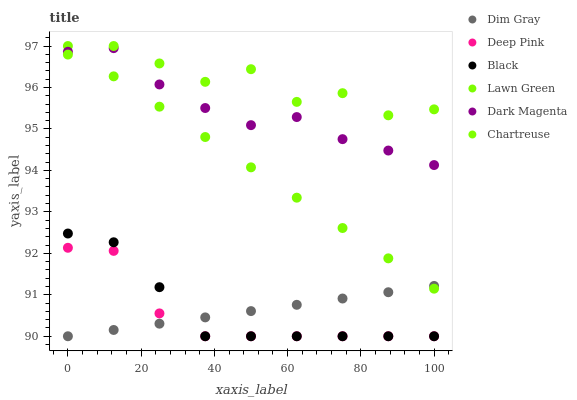Does Deep Pink have the minimum area under the curve?
Answer yes or no. Yes. Does Chartreuse have the maximum area under the curve?
Answer yes or no. Yes. Does Dim Gray have the minimum area under the curve?
Answer yes or no. No. Does Dim Gray have the maximum area under the curve?
Answer yes or no. No. Is Lawn Green the smoothest?
Answer yes or no. Yes. Is Chartreuse the roughest?
Answer yes or no. Yes. Is Dim Gray the smoothest?
Answer yes or no. No. Is Dim Gray the roughest?
Answer yes or no. No. Does Dim Gray have the lowest value?
Answer yes or no. Yes. Does Dark Magenta have the lowest value?
Answer yes or no. No. Does Chartreuse have the highest value?
Answer yes or no. Yes. Does Dark Magenta have the highest value?
Answer yes or no. No. Is Deep Pink less than Dark Magenta?
Answer yes or no. Yes. Is Dark Magenta greater than Dim Gray?
Answer yes or no. Yes. Does Lawn Green intersect Dim Gray?
Answer yes or no. Yes. Is Lawn Green less than Dim Gray?
Answer yes or no. No. Is Lawn Green greater than Dim Gray?
Answer yes or no. No. Does Deep Pink intersect Dark Magenta?
Answer yes or no. No. 